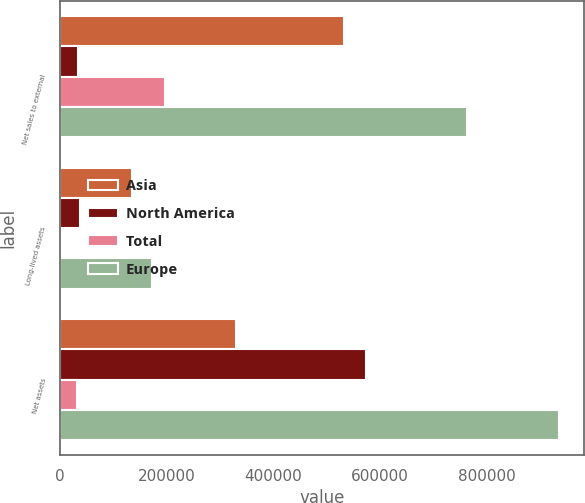<chart> <loc_0><loc_0><loc_500><loc_500><stacked_bar_chart><ecel><fcel>Net sales to external<fcel>Long-lived assets<fcel>Net assets<nl><fcel>Asia<fcel>532501<fcel>133832<fcel>330350<nl><fcel>North America<fcel>34185<fcel>37341<fcel>573363<nl><fcel>Total<fcel>195863<fcel>457<fcel>31874<nl><fcel>Europe<fcel>762549<fcel>171630<fcel>935587<nl></chart> 